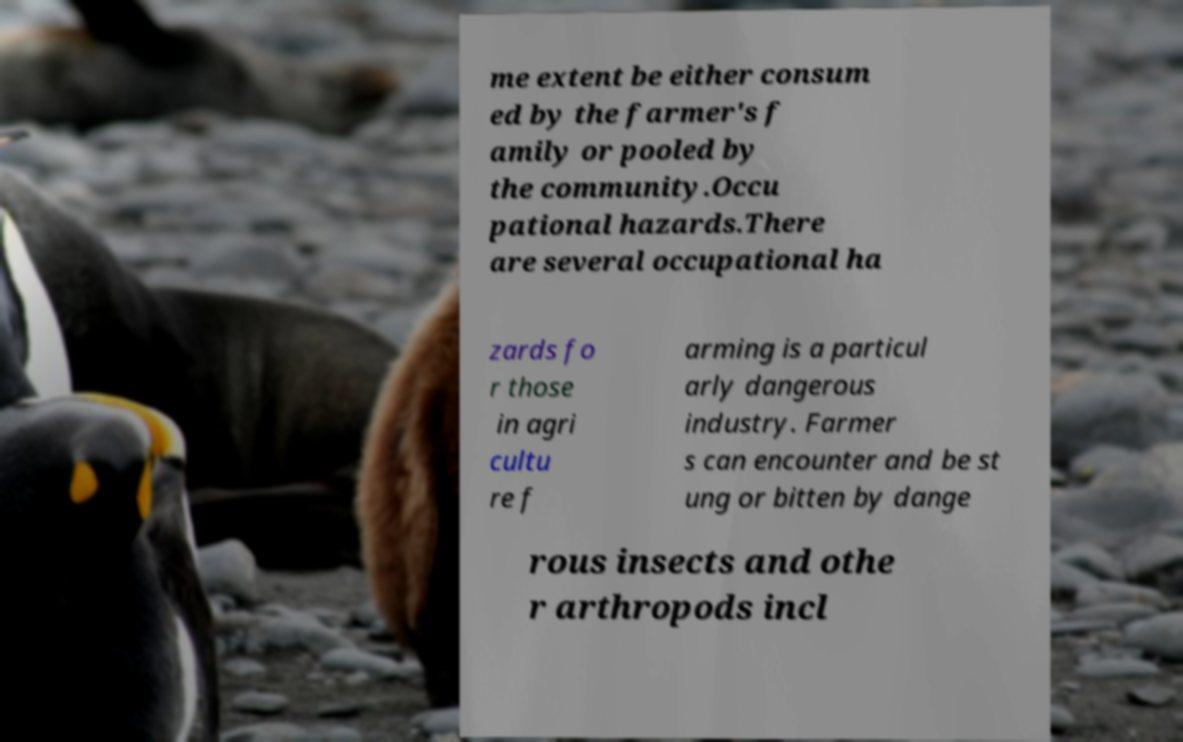For documentation purposes, I need the text within this image transcribed. Could you provide that? me extent be either consum ed by the farmer's f amily or pooled by the community.Occu pational hazards.There are several occupational ha zards fo r those in agri cultu re f arming is a particul arly dangerous industry. Farmer s can encounter and be st ung or bitten by dange rous insects and othe r arthropods incl 